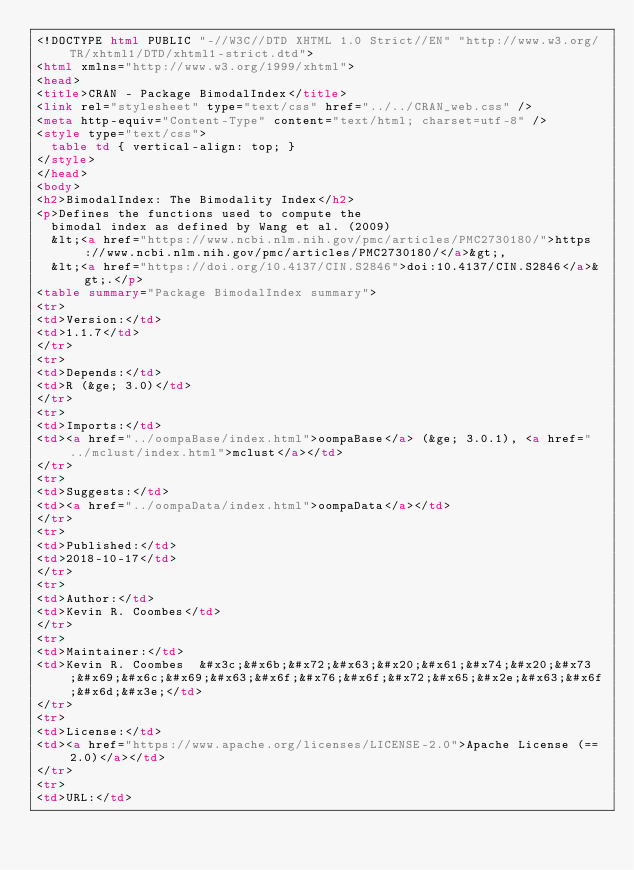<code> <loc_0><loc_0><loc_500><loc_500><_HTML_><!DOCTYPE html PUBLIC "-//W3C//DTD XHTML 1.0 Strict//EN" "http://www.w3.org/TR/xhtml1/DTD/xhtml1-strict.dtd">
<html xmlns="http://www.w3.org/1999/xhtml">
<head>
<title>CRAN - Package BimodalIndex</title>
<link rel="stylesheet" type="text/css" href="../../CRAN_web.css" />
<meta http-equiv="Content-Type" content="text/html; charset=utf-8" />
<style type="text/css">
  table td { vertical-align: top; }
</style>
</head>
<body>
<h2>BimodalIndex: The Bimodality Index</h2>
<p>Defines the functions used to compute the
  bimodal index as defined by Wang et al. (2009)
  &lt;<a href="https://www.ncbi.nlm.nih.gov/pmc/articles/PMC2730180/">https://www.ncbi.nlm.nih.gov/pmc/articles/PMC2730180/</a>&gt;,
  &lt;<a href="https://doi.org/10.4137/CIN.S2846">doi:10.4137/CIN.S2846</a>&gt;.</p>
<table summary="Package BimodalIndex summary">
<tr>
<td>Version:</td>
<td>1.1.7</td>
</tr>
<tr>
<td>Depends:</td>
<td>R (&ge; 3.0)</td>
</tr>
<tr>
<td>Imports:</td>
<td><a href="../oompaBase/index.html">oompaBase</a> (&ge; 3.0.1), <a href="../mclust/index.html">mclust</a></td>
</tr>
<tr>
<td>Suggests:</td>
<td><a href="../oompaData/index.html">oompaData</a></td>
</tr>
<tr>
<td>Published:</td>
<td>2018-10-17</td>
</tr>
<tr>
<td>Author:</td>
<td>Kevin R. Coombes</td>
</tr>
<tr>
<td>Maintainer:</td>
<td>Kevin R. Coombes  &#x3c;&#x6b;&#x72;&#x63;&#x20;&#x61;&#x74;&#x20;&#x73;&#x69;&#x6c;&#x69;&#x63;&#x6f;&#x76;&#x6f;&#x72;&#x65;&#x2e;&#x63;&#x6f;&#x6d;&#x3e;</td>
</tr>
<tr>
<td>License:</td>
<td><a href="https://www.apache.org/licenses/LICENSE-2.0">Apache License (== 2.0)</a></td>
</tr>
<tr>
<td>URL:</td></code> 